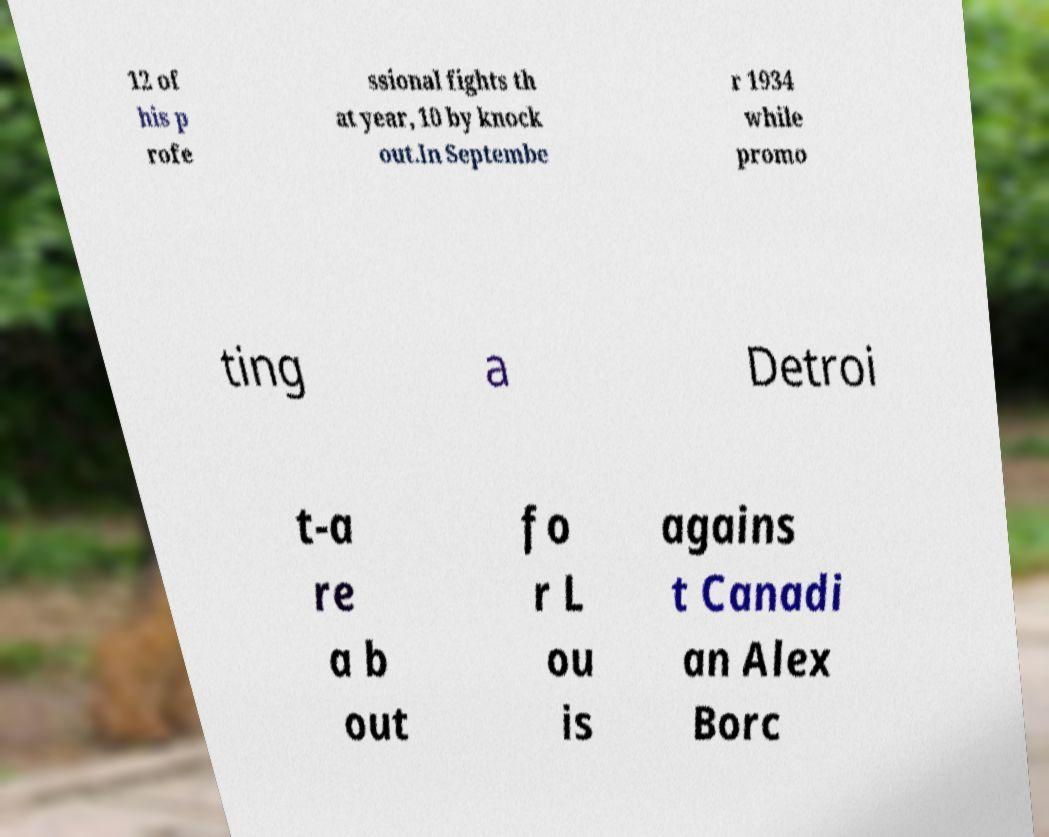Can you read and provide the text displayed in the image?This photo seems to have some interesting text. Can you extract and type it out for me? 12 of his p rofe ssional fights th at year, 10 by knock out.In Septembe r 1934 while promo ting a Detroi t-a re a b out fo r L ou is agains t Canadi an Alex Borc 